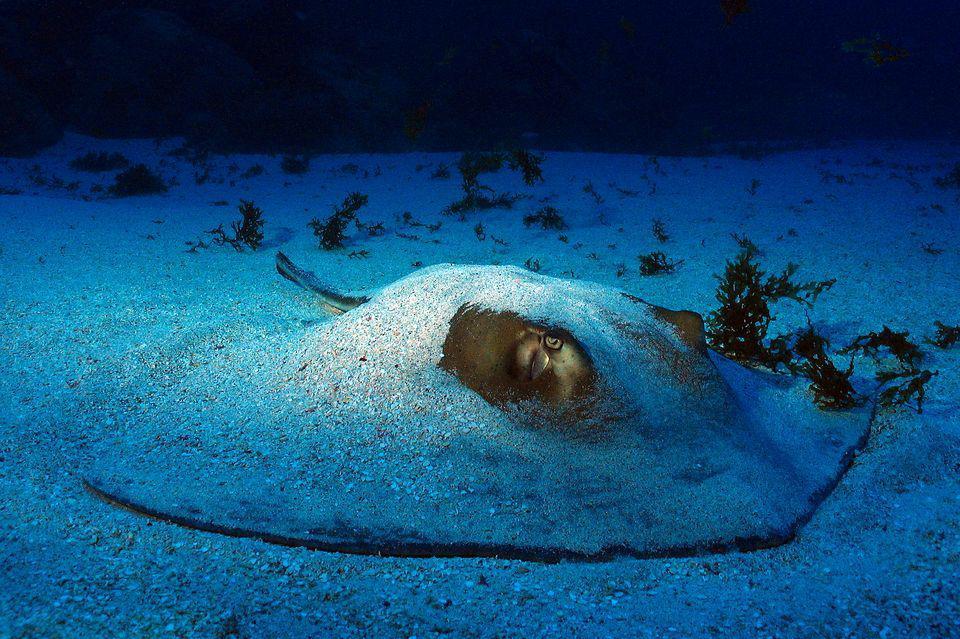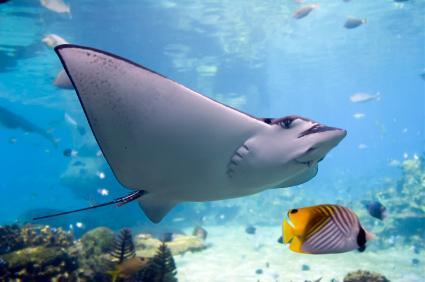The first image is the image on the left, the second image is the image on the right. Evaluate the accuracy of this statement regarding the images: "There are at least two rays in at least one of the images.". Is it true? Answer yes or no. No. The first image is the image on the left, the second image is the image on the right. Examine the images to the left and right. Is the description "An image shows one rightward-facing stingray that is partly covered in sand." accurate? Answer yes or no. Yes. The first image is the image on the left, the second image is the image on the right. Evaluate the accuracy of this statement regarding the images: "The underside of a stingray, including its mouth, is visible in the right-hand image.". Is it true? Answer yes or no. Yes. The first image is the image on the left, the second image is the image on the right. For the images displayed, is the sentence "A single ray is sitting on the sandy bottom in the image on the left." factually correct? Answer yes or no. Yes. 